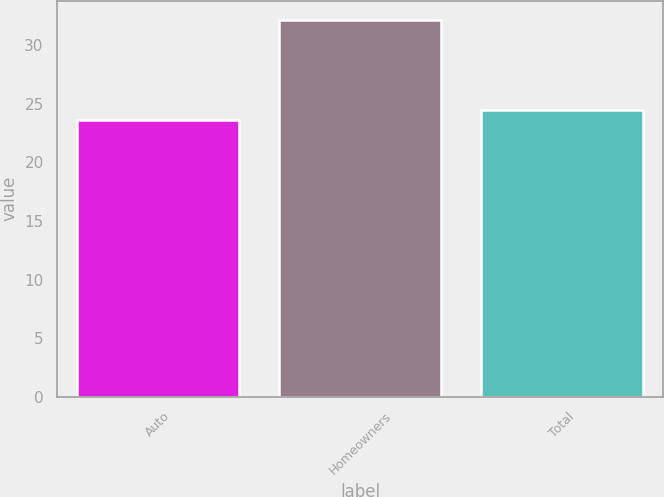<chart> <loc_0><loc_0><loc_500><loc_500><bar_chart><fcel>Auto<fcel>Homeowners<fcel>Total<nl><fcel>23.6<fcel>32.2<fcel>24.46<nl></chart> 